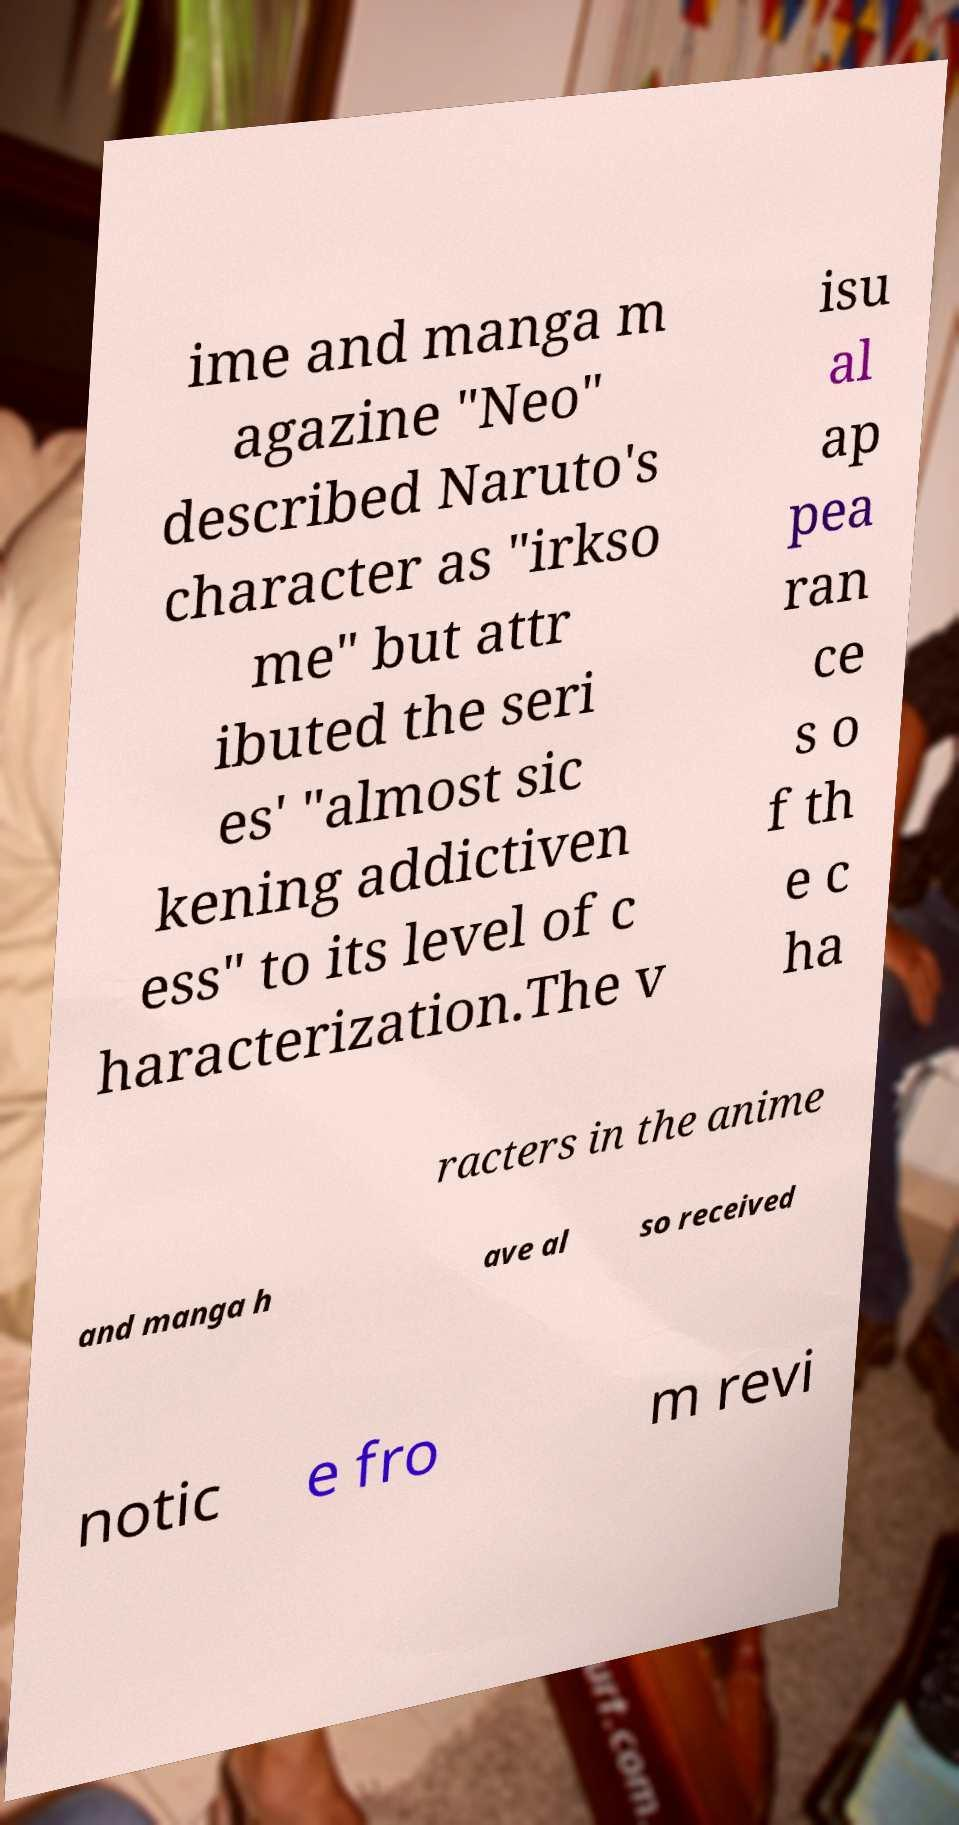There's text embedded in this image that I need extracted. Can you transcribe it verbatim? ime and manga m agazine "Neo" described Naruto's character as "irkso me" but attr ibuted the seri es' "almost sic kening addictiven ess" to its level of c haracterization.The v isu al ap pea ran ce s o f th e c ha racters in the anime and manga h ave al so received notic e fro m revi 